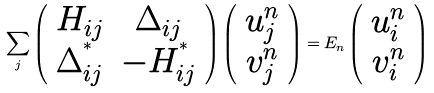Convert formula to latex. <formula><loc_0><loc_0><loc_500><loc_500>\sum _ { j } \left ( \begin{array} { c c } H _ { i j } & \Delta _ { i j } \\ \Delta ^ { ^ { * } } _ { i j } & - H ^ { ^ { * } } _ { i j } \end{array} \right ) \left ( \begin{array} { c } u _ { j } ^ { n } \\ v _ { j } ^ { n } \end{array} \right ) = E _ { n } \left ( \begin{array} { c } u _ { i } ^ { n } \\ v _ { i } ^ { n } \end{array} \right )</formula> 